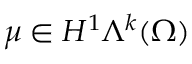<formula> <loc_0><loc_0><loc_500><loc_500>\mu \in H ^ { 1 } \Lambda ^ { k } ( \Omega )</formula> 